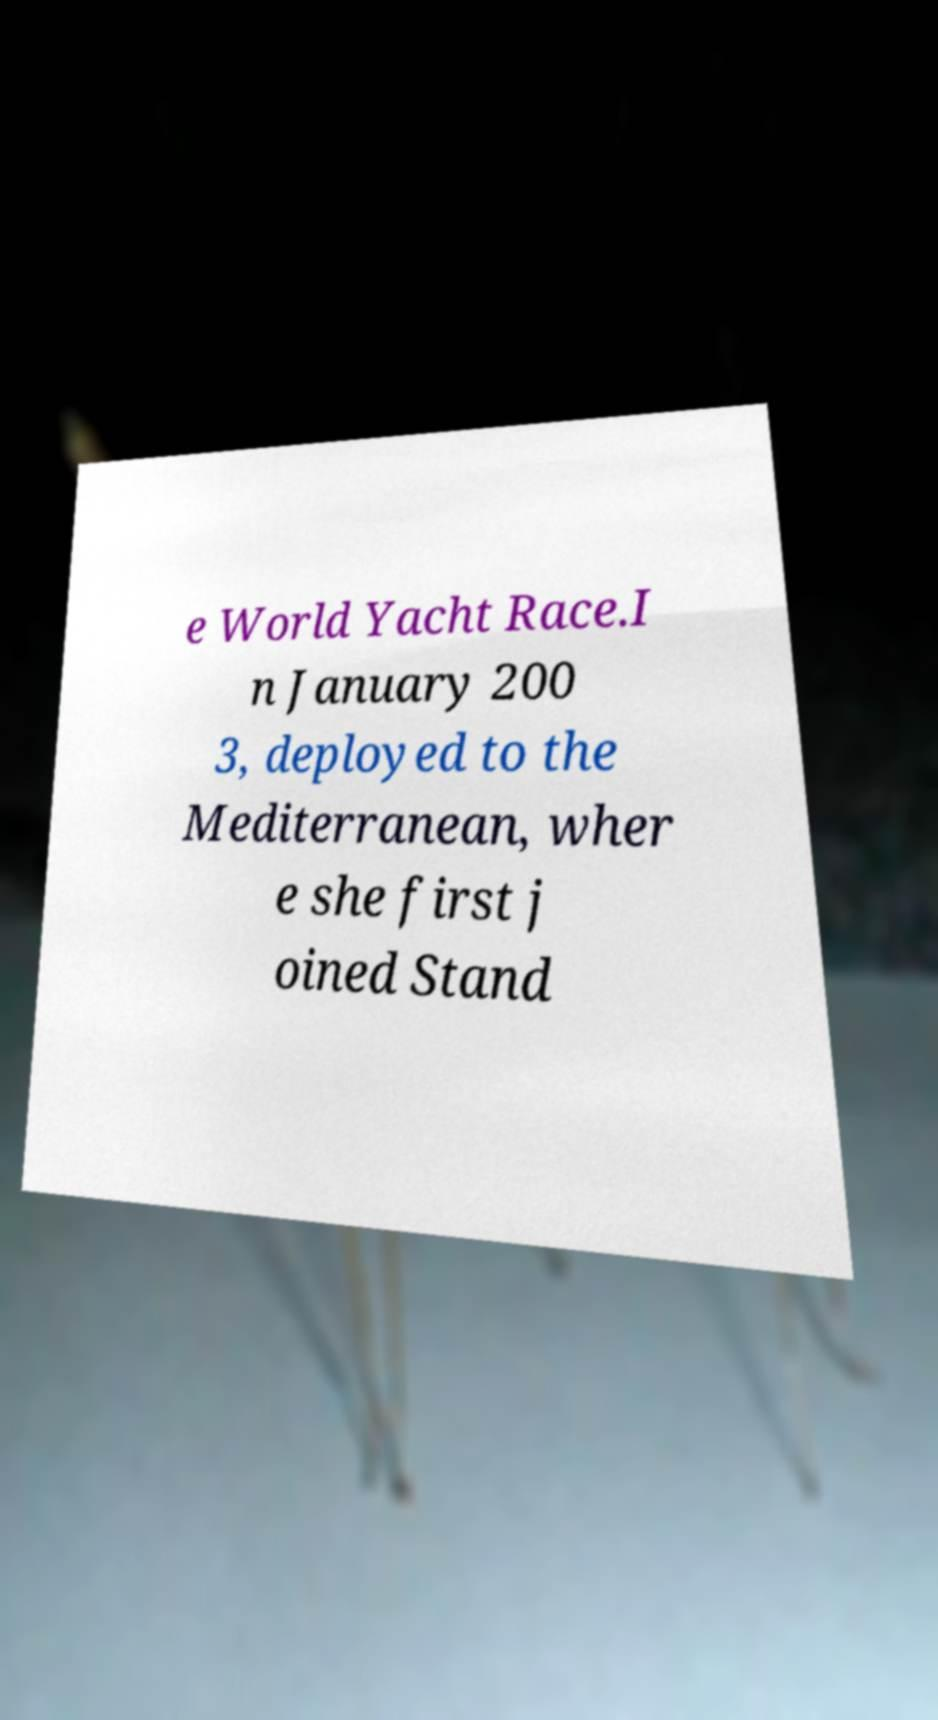Please identify and transcribe the text found in this image. e World Yacht Race.I n January 200 3, deployed to the Mediterranean, wher e she first j oined Stand 